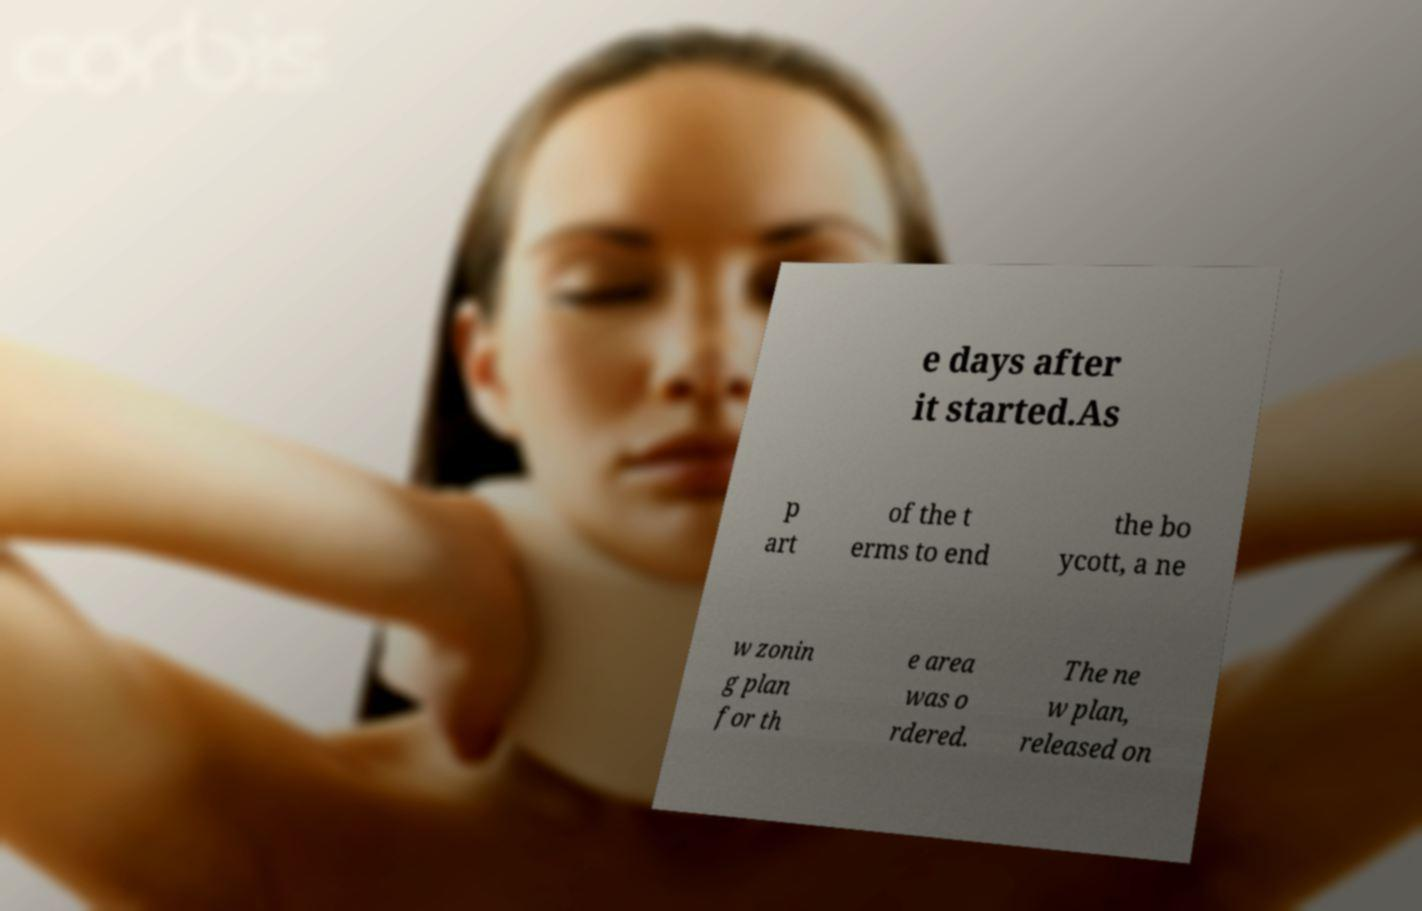Can you read and provide the text displayed in the image?This photo seems to have some interesting text. Can you extract and type it out for me? e days after it started.As p art of the t erms to end the bo ycott, a ne w zonin g plan for th e area was o rdered. The ne w plan, released on 